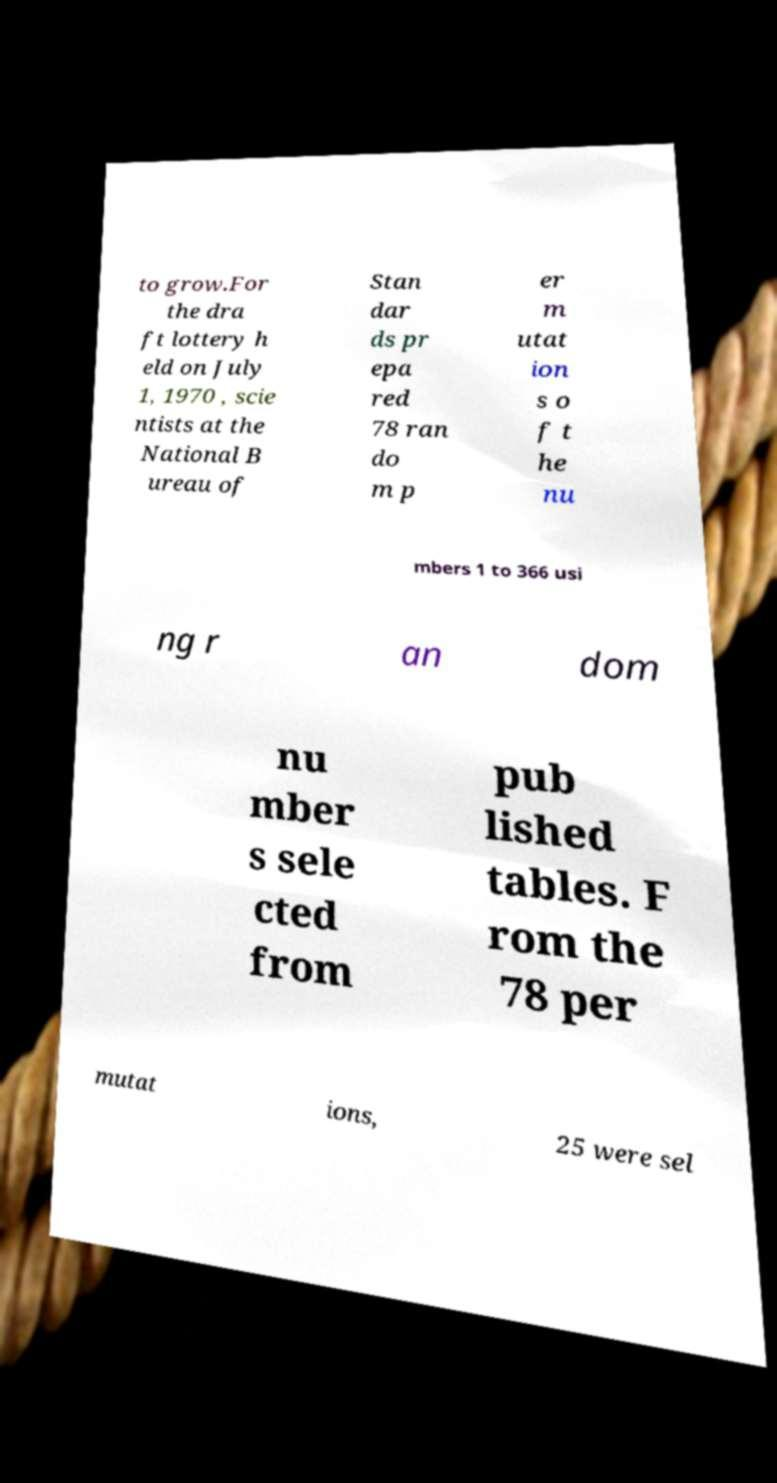What messages or text are displayed in this image? I need them in a readable, typed format. to grow.For the dra ft lottery h eld on July 1, 1970 , scie ntists at the National B ureau of Stan dar ds pr epa red 78 ran do m p er m utat ion s o f t he nu mbers 1 to 366 usi ng r an dom nu mber s sele cted from pub lished tables. F rom the 78 per mutat ions, 25 were sel 